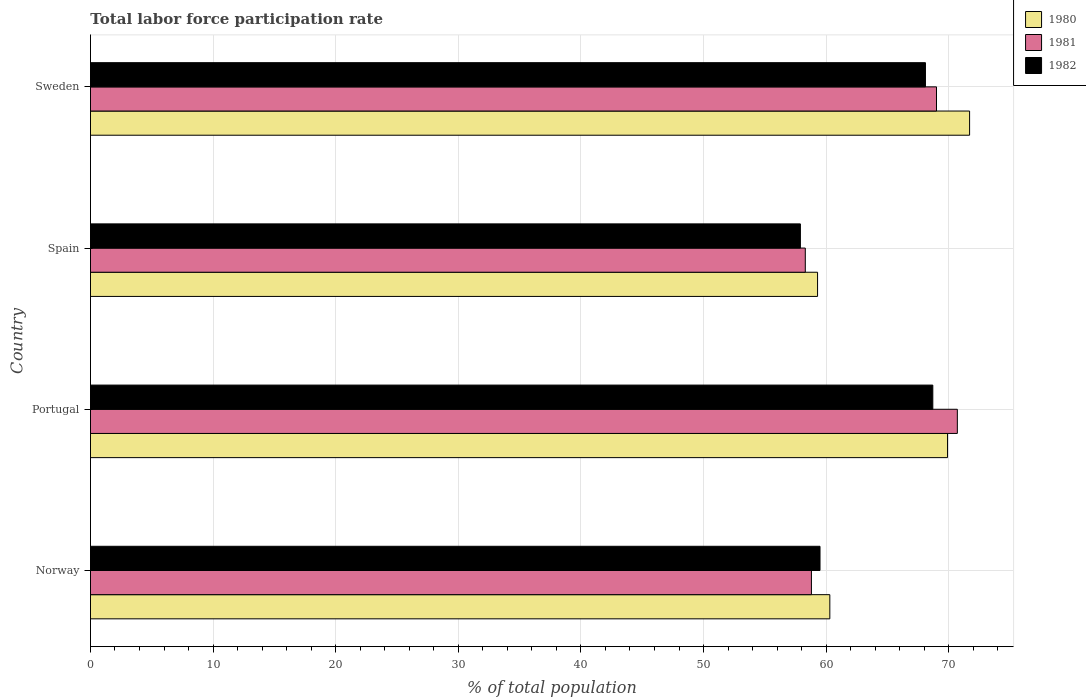Are the number of bars on each tick of the Y-axis equal?
Your response must be concise. Yes. How many bars are there on the 3rd tick from the bottom?
Give a very brief answer. 3. In how many cases, is the number of bars for a given country not equal to the number of legend labels?
Give a very brief answer. 0. What is the total labor force participation rate in 1982 in Sweden?
Your answer should be very brief. 68.1. Across all countries, what is the maximum total labor force participation rate in 1982?
Your answer should be compact. 68.7. Across all countries, what is the minimum total labor force participation rate in 1980?
Provide a succinct answer. 59.3. In which country was the total labor force participation rate in 1981 minimum?
Your answer should be very brief. Spain. What is the total total labor force participation rate in 1980 in the graph?
Keep it short and to the point. 261.2. What is the difference between the total labor force participation rate in 1980 in Norway and the total labor force participation rate in 1982 in Sweden?
Ensure brevity in your answer.  -7.8. What is the average total labor force participation rate in 1981 per country?
Make the answer very short. 64.2. What is the difference between the total labor force participation rate in 1982 and total labor force participation rate in 1981 in Norway?
Your answer should be very brief. 0.7. In how many countries, is the total labor force participation rate in 1981 greater than 30 %?
Your answer should be very brief. 4. What is the ratio of the total labor force participation rate in 1981 in Norway to that in Spain?
Keep it short and to the point. 1.01. What is the difference between the highest and the second highest total labor force participation rate in 1980?
Provide a short and direct response. 1.8. What is the difference between the highest and the lowest total labor force participation rate in 1982?
Provide a short and direct response. 10.8. In how many countries, is the total labor force participation rate in 1982 greater than the average total labor force participation rate in 1982 taken over all countries?
Keep it short and to the point. 2. Is the sum of the total labor force participation rate in 1981 in Norway and Portugal greater than the maximum total labor force participation rate in 1980 across all countries?
Your answer should be compact. Yes. What does the 3rd bar from the bottom in Spain represents?
Provide a succinct answer. 1982. Is it the case that in every country, the sum of the total labor force participation rate in 1981 and total labor force participation rate in 1982 is greater than the total labor force participation rate in 1980?
Provide a short and direct response. Yes. Are all the bars in the graph horizontal?
Your answer should be very brief. Yes. What is the difference between two consecutive major ticks on the X-axis?
Give a very brief answer. 10. Are the values on the major ticks of X-axis written in scientific E-notation?
Your response must be concise. No. Does the graph contain any zero values?
Give a very brief answer. No. Does the graph contain grids?
Your answer should be compact. Yes. Where does the legend appear in the graph?
Ensure brevity in your answer.  Top right. How many legend labels are there?
Provide a short and direct response. 3. How are the legend labels stacked?
Provide a short and direct response. Vertical. What is the title of the graph?
Your answer should be very brief. Total labor force participation rate. What is the label or title of the X-axis?
Offer a terse response. % of total population. What is the % of total population in 1980 in Norway?
Provide a succinct answer. 60.3. What is the % of total population of 1981 in Norway?
Offer a terse response. 58.8. What is the % of total population of 1982 in Norway?
Your answer should be very brief. 59.5. What is the % of total population of 1980 in Portugal?
Provide a succinct answer. 69.9. What is the % of total population in 1981 in Portugal?
Offer a terse response. 70.7. What is the % of total population of 1982 in Portugal?
Give a very brief answer. 68.7. What is the % of total population in 1980 in Spain?
Your response must be concise. 59.3. What is the % of total population of 1981 in Spain?
Your response must be concise. 58.3. What is the % of total population of 1982 in Spain?
Offer a very short reply. 57.9. What is the % of total population in 1980 in Sweden?
Your answer should be compact. 71.7. What is the % of total population of 1981 in Sweden?
Make the answer very short. 69. What is the % of total population in 1982 in Sweden?
Provide a short and direct response. 68.1. Across all countries, what is the maximum % of total population in 1980?
Give a very brief answer. 71.7. Across all countries, what is the maximum % of total population in 1981?
Your answer should be compact. 70.7. Across all countries, what is the maximum % of total population in 1982?
Provide a succinct answer. 68.7. Across all countries, what is the minimum % of total population in 1980?
Offer a terse response. 59.3. Across all countries, what is the minimum % of total population of 1981?
Ensure brevity in your answer.  58.3. Across all countries, what is the minimum % of total population of 1982?
Keep it short and to the point. 57.9. What is the total % of total population of 1980 in the graph?
Offer a very short reply. 261.2. What is the total % of total population in 1981 in the graph?
Offer a very short reply. 256.8. What is the total % of total population in 1982 in the graph?
Give a very brief answer. 254.2. What is the difference between the % of total population of 1980 in Norway and that in Portugal?
Provide a succinct answer. -9.6. What is the difference between the % of total population in 1981 in Norway and that in Portugal?
Give a very brief answer. -11.9. What is the difference between the % of total population of 1982 in Norway and that in Portugal?
Your answer should be very brief. -9.2. What is the difference between the % of total population in 1982 in Norway and that in Spain?
Provide a succinct answer. 1.6. What is the difference between the % of total population in 1980 in Norway and that in Sweden?
Offer a very short reply. -11.4. What is the difference between the % of total population in 1981 in Norway and that in Sweden?
Provide a succinct answer. -10.2. What is the difference between the % of total population of 1982 in Norway and that in Sweden?
Give a very brief answer. -8.6. What is the difference between the % of total population of 1980 in Portugal and that in Spain?
Your answer should be compact. 10.6. What is the difference between the % of total population of 1981 in Portugal and that in Spain?
Your answer should be very brief. 12.4. What is the difference between the % of total population in 1982 in Portugal and that in Spain?
Your answer should be very brief. 10.8. What is the difference between the % of total population in 1981 in Spain and that in Sweden?
Offer a very short reply. -10.7. What is the difference between the % of total population of 1982 in Spain and that in Sweden?
Ensure brevity in your answer.  -10.2. What is the difference between the % of total population in 1981 in Norway and the % of total population in 1982 in Portugal?
Offer a terse response. -9.9. What is the difference between the % of total population of 1980 in Norway and the % of total population of 1981 in Spain?
Keep it short and to the point. 2. What is the difference between the % of total population in 1980 in Norway and the % of total population in 1981 in Sweden?
Make the answer very short. -8.7. What is the difference between the % of total population in 1980 in Norway and the % of total population in 1982 in Sweden?
Your response must be concise. -7.8. What is the difference between the % of total population in 1981 in Norway and the % of total population in 1982 in Sweden?
Make the answer very short. -9.3. What is the difference between the % of total population in 1980 in Portugal and the % of total population in 1981 in Spain?
Offer a very short reply. 11.6. What is the difference between the % of total population in 1981 in Portugal and the % of total population in 1982 in Spain?
Provide a short and direct response. 12.8. What is the difference between the % of total population of 1980 in Portugal and the % of total population of 1982 in Sweden?
Keep it short and to the point. 1.8. What is the difference between the % of total population of 1981 in Portugal and the % of total population of 1982 in Sweden?
Give a very brief answer. 2.6. What is the difference between the % of total population in 1981 in Spain and the % of total population in 1982 in Sweden?
Offer a very short reply. -9.8. What is the average % of total population in 1980 per country?
Your answer should be compact. 65.3. What is the average % of total population of 1981 per country?
Keep it short and to the point. 64.2. What is the average % of total population of 1982 per country?
Ensure brevity in your answer.  63.55. What is the difference between the % of total population in 1981 and % of total population in 1982 in Norway?
Offer a terse response. -0.7. What is the difference between the % of total population of 1981 and % of total population of 1982 in Portugal?
Provide a succinct answer. 2. What is the difference between the % of total population of 1980 and % of total population of 1982 in Spain?
Give a very brief answer. 1.4. What is the difference between the % of total population of 1981 and % of total population of 1982 in Spain?
Your response must be concise. 0.4. What is the difference between the % of total population of 1980 and % of total population of 1981 in Sweden?
Offer a terse response. 2.7. What is the difference between the % of total population of 1981 and % of total population of 1982 in Sweden?
Your answer should be very brief. 0.9. What is the ratio of the % of total population of 1980 in Norway to that in Portugal?
Give a very brief answer. 0.86. What is the ratio of the % of total population in 1981 in Norway to that in Portugal?
Provide a short and direct response. 0.83. What is the ratio of the % of total population in 1982 in Norway to that in Portugal?
Ensure brevity in your answer.  0.87. What is the ratio of the % of total population of 1980 in Norway to that in Spain?
Your response must be concise. 1.02. What is the ratio of the % of total population in 1981 in Norway to that in Spain?
Your answer should be very brief. 1.01. What is the ratio of the % of total population of 1982 in Norway to that in Spain?
Give a very brief answer. 1.03. What is the ratio of the % of total population in 1980 in Norway to that in Sweden?
Your response must be concise. 0.84. What is the ratio of the % of total population in 1981 in Norway to that in Sweden?
Provide a succinct answer. 0.85. What is the ratio of the % of total population in 1982 in Norway to that in Sweden?
Your answer should be very brief. 0.87. What is the ratio of the % of total population of 1980 in Portugal to that in Spain?
Give a very brief answer. 1.18. What is the ratio of the % of total population of 1981 in Portugal to that in Spain?
Keep it short and to the point. 1.21. What is the ratio of the % of total population of 1982 in Portugal to that in Spain?
Your answer should be compact. 1.19. What is the ratio of the % of total population of 1980 in Portugal to that in Sweden?
Keep it short and to the point. 0.97. What is the ratio of the % of total population in 1981 in Portugal to that in Sweden?
Your answer should be very brief. 1.02. What is the ratio of the % of total population in 1982 in Portugal to that in Sweden?
Give a very brief answer. 1.01. What is the ratio of the % of total population of 1980 in Spain to that in Sweden?
Give a very brief answer. 0.83. What is the ratio of the % of total population in 1981 in Spain to that in Sweden?
Provide a succinct answer. 0.84. What is the ratio of the % of total population in 1982 in Spain to that in Sweden?
Provide a short and direct response. 0.85. What is the difference between the highest and the second highest % of total population in 1980?
Your response must be concise. 1.8. What is the difference between the highest and the second highest % of total population in 1982?
Ensure brevity in your answer.  0.6. What is the difference between the highest and the lowest % of total population in 1981?
Your answer should be very brief. 12.4. What is the difference between the highest and the lowest % of total population of 1982?
Your answer should be very brief. 10.8. 